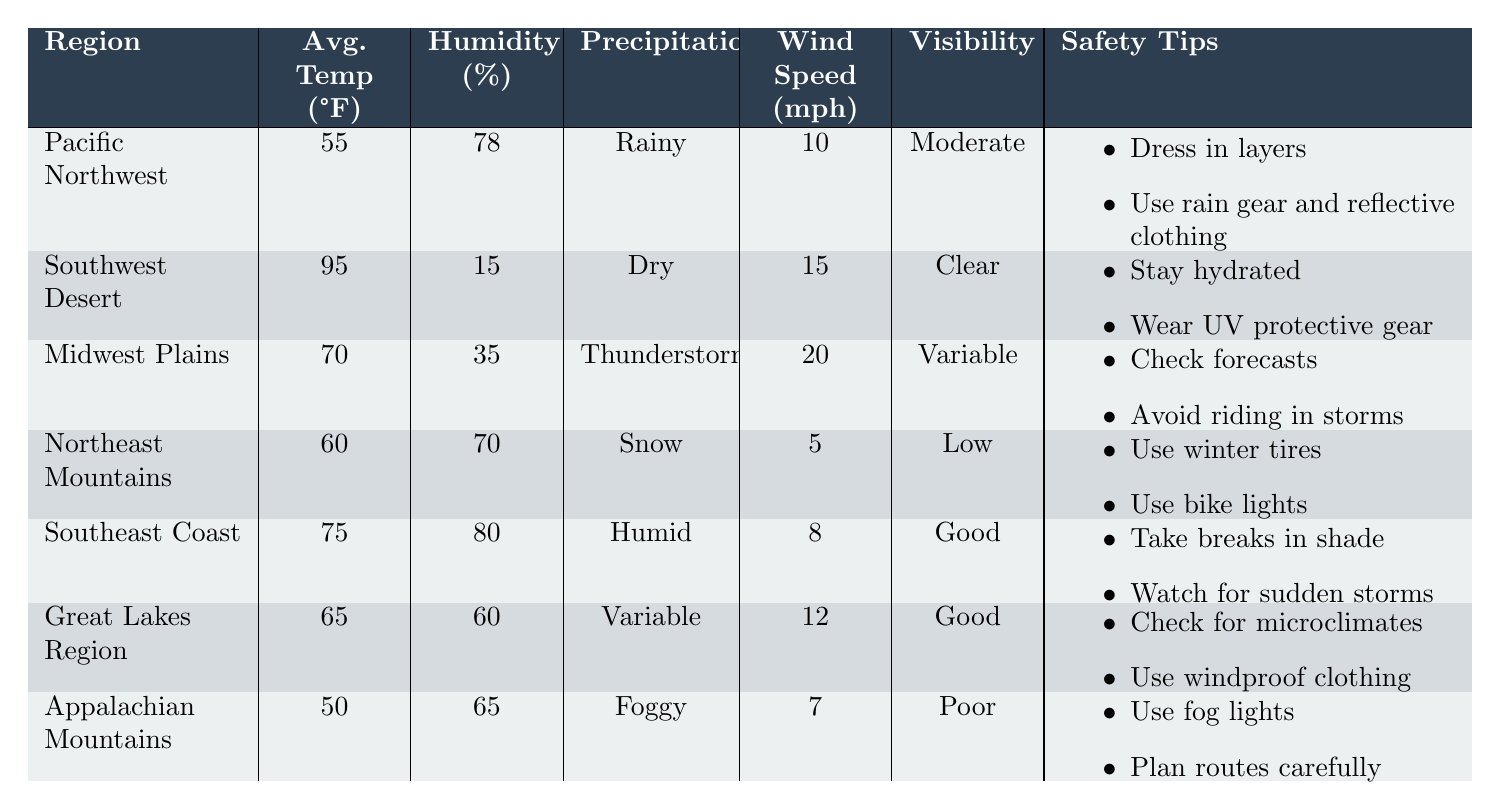What is the average temperature in the Appalachian Mountains? The table lists the average temperature for the Appalachian Mountains as 50°F.
Answer: 50°F Which region has the highest wind speed, and what is that speed? The table indicates that the Midwest Plains have the highest wind speed at 20 mph.
Answer: Midwest Plains, 20 mph How many regions have an average humidity above 70%? The Pacific Northwest (78%) and Southeast Coast (80%) are above 70%, totaling 2 regions.
Answer: 2 Are there any regions with low visibility? The table shows that the Northeast Mountains (Low visibility) and Appalachian Mountains (Poor visibility) have low visibility. Therefore, the answer is yes.
Answer: Yes What is the difference in average temperature between the Southeast Coast and the Southwest Desert? The Southeast Coast has an average temperature of 75°F, and the Southwest Desert has 95°F. The difference is 95 - 75 = 20°F.
Answer: 20°F What safety tip is common to both the Midwest Plains and the Great Lakes Region? Both regions include a safety tip regarding checking weather conditions and forecasts.
Answer: Check weather conditions How does the average temperature of the Northeast Mountains compare to the Great Lakes Region? The Northeast Mountains have an average temperature of 60°F and the Great Lakes Region has 65°F. Thus, the Great Lakes Region is warmer by 5°F.
Answer: Great Lakes Region is 5°F warmer Which region has the lowest average temperature, and how does that compare against the Pacific Northwest? The Appalachian Mountains have the lowest average temperature at 50°F, and it's 5°F lower than the Pacific Northwest’s 55°F.
Answer: Appalachian Mountains, 5°F lower Is the average humidity in the Southwest Desert below or above 30%? The Southwest Desert has an average humidity of 15%, which is well below 30%.
Answer: Below What visibility conditions are listed for regions experiencing precipitation, and what implications does this have for safety? The Northeast Mountains have low visibility during snow, Appalachian Mountains experience poor visibility in fog, and both imply that bikers should be cautious and ensure visibility equipment is in use.
Answer: Low and poor visibility indicates caution is needed 